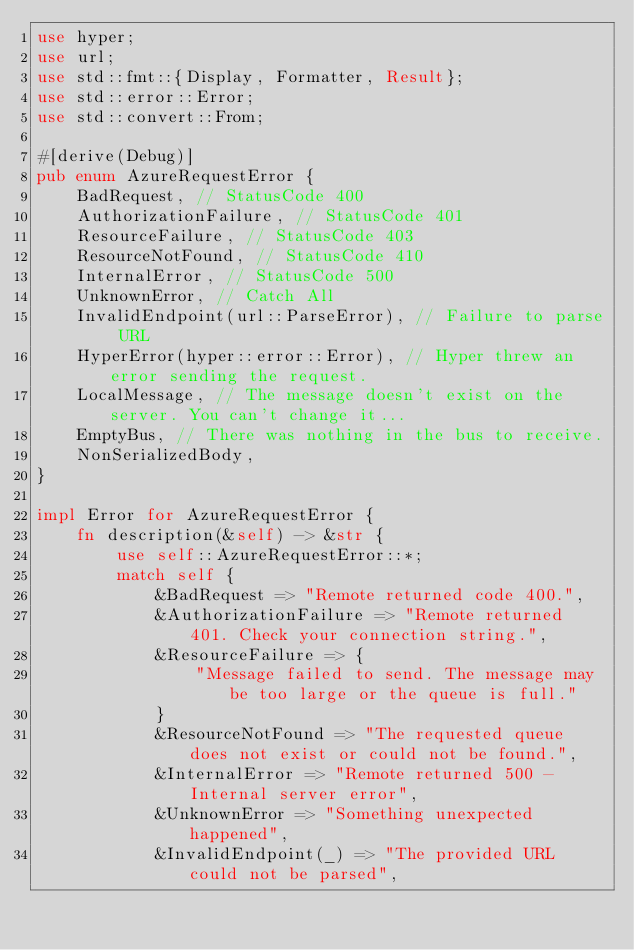<code> <loc_0><loc_0><loc_500><loc_500><_Rust_>use hyper;
use url;
use std::fmt::{Display, Formatter, Result};
use std::error::Error;
use std::convert::From;

#[derive(Debug)]
pub enum AzureRequestError {
    BadRequest, // StatusCode 400
    AuthorizationFailure, // StatusCode 401
    ResourceFailure, // StatusCode 403
    ResourceNotFound, // StatusCode 410
    InternalError, // StatusCode 500
    UnknownError, // Catch All
    InvalidEndpoint(url::ParseError), // Failure to parse URL
    HyperError(hyper::error::Error), // Hyper threw an error sending the request.
    LocalMessage, // The message doesn't exist on the server. You can't change it...
    EmptyBus, // There was nothing in the bus to receive.
    NonSerializedBody,
}

impl Error for AzureRequestError {
    fn description(&self) -> &str {
        use self::AzureRequestError::*;
        match self {
            &BadRequest => "Remote returned code 400.",
            &AuthorizationFailure => "Remote returned 401. Check your connection string.",
            &ResourceFailure => {
                "Message failed to send. The message may be too large or the queue is full."
            }
            &ResourceNotFound => "The requested queue does not exist or could not be found.",
            &InternalError => "Remote returned 500 - Internal server error",
            &UnknownError => "Something unexpected happened",
            &InvalidEndpoint(_) => "The provided URL could not be parsed",</code> 